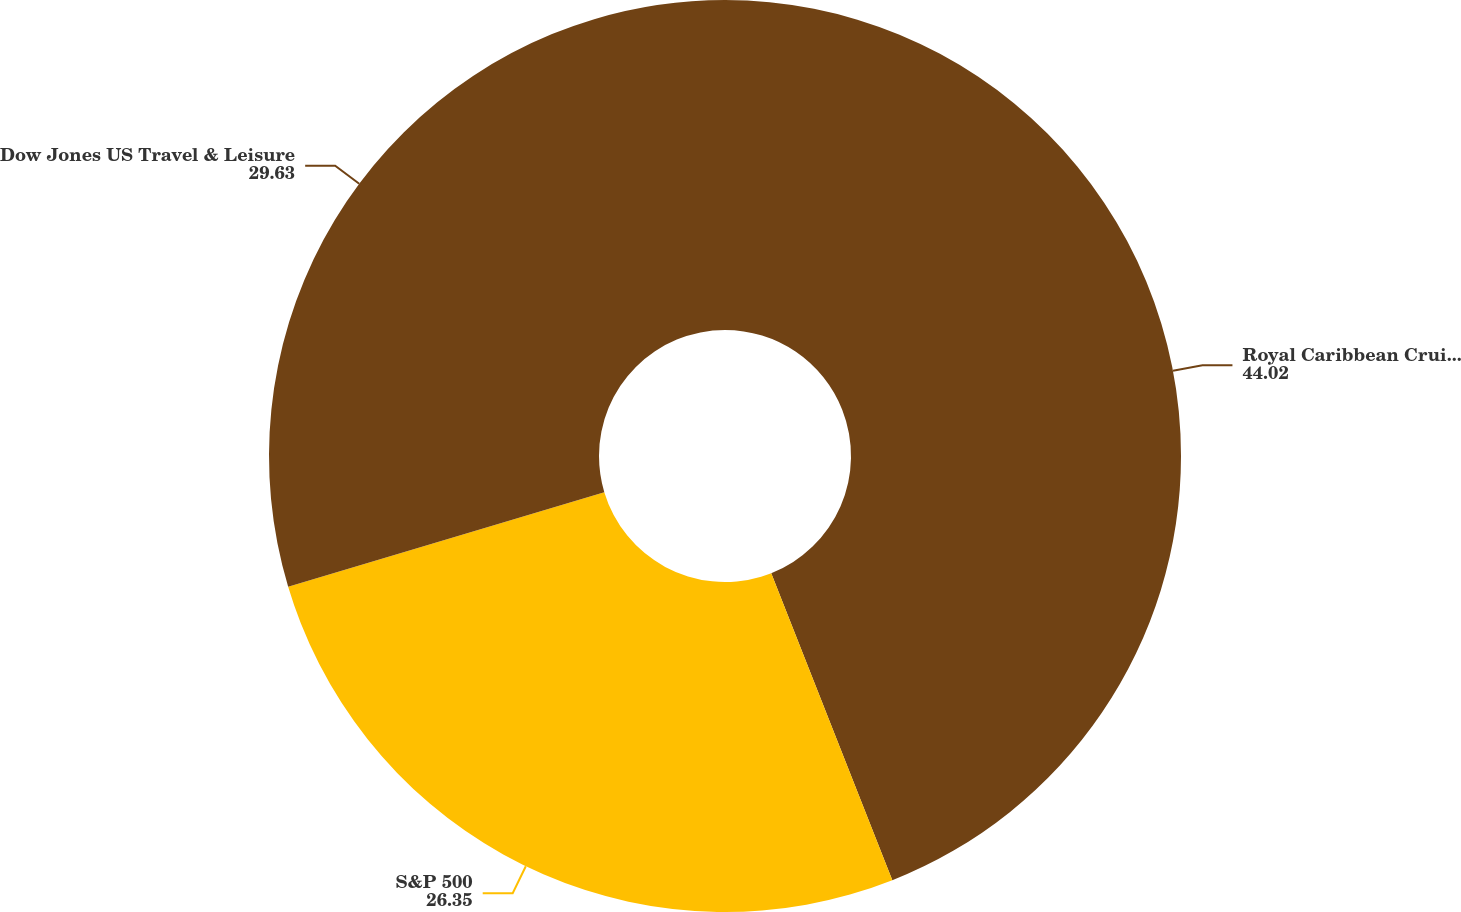Convert chart to OTSL. <chart><loc_0><loc_0><loc_500><loc_500><pie_chart><fcel>Royal Caribbean Cruises Ltd<fcel>S&P 500<fcel>Dow Jones US Travel & Leisure<nl><fcel>44.02%<fcel>26.35%<fcel>29.63%<nl></chart> 